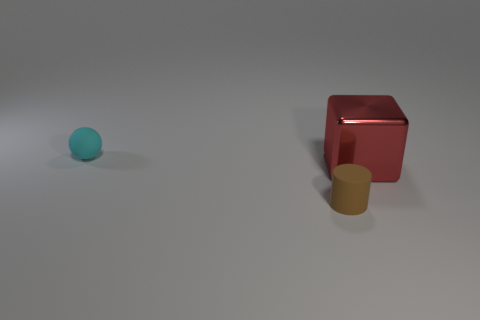Add 1 tiny blue rubber balls. How many objects exist? 4 Subtract all spheres. How many objects are left? 2 Subtract 1 cylinders. How many cylinders are left? 0 Add 1 cylinders. How many cylinders exist? 2 Subtract 0 brown spheres. How many objects are left? 3 Subtract all yellow spheres. Subtract all cyan cylinders. How many spheres are left? 1 Subtract all cyan cylinders. How many yellow balls are left? 0 Subtract all red metal things. Subtract all tiny gray shiny cubes. How many objects are left? 2 Add 1 big red shiny things. How many big red shiny things are left? 2 